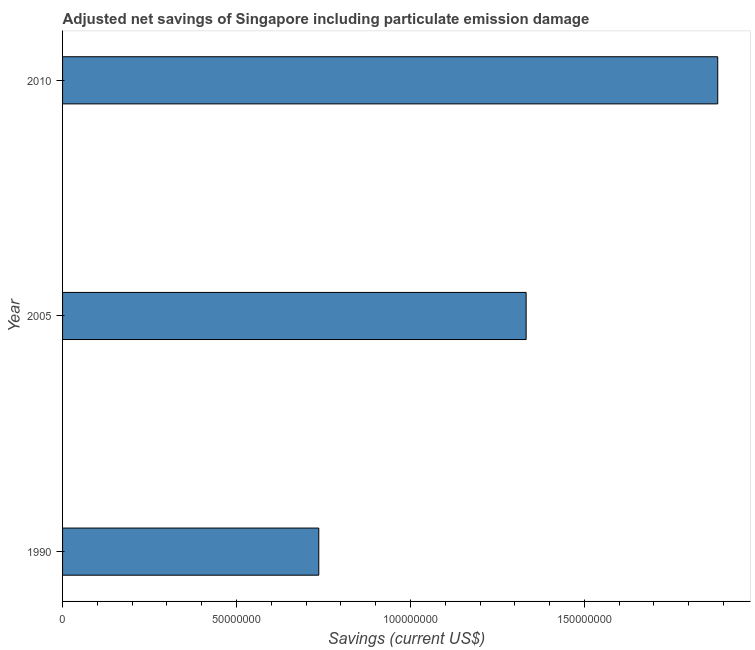What is the title of the graph?
Ensure brevity in your answer.  Adjusted net savings of Singapore including particulate emission damage. What is the label or title of the X-axis?
Offer a terse response. Savings (current US$). What is the label or title of the Y-axis?
Offer a very short reply. Year. What is the adjusted net savings in 2010?
Provide a short and direct response. 1.88e+08. Across all years, what is the maximum adjusted net savings?
Give a very brief answer. 1.88e+08. Across all years, what is the minimum adjusted net savings?
Make the answer very short. 7.36e+07. What is the sum of the adjusted net savings?
Give a very brief answer. 3.95e+08. What is the difference between the adjusted net savings in 1990 and 2005?
Provide a short and direct response. -5.96e+07. What is the average adjusted net savings per year?
Make the answer very short. 1.32e+08. What is the median adjusted net savings?
Offer a very short reply. 1.33e+08. In how many years, is the adjusted net savings greater than 80000000 US$?
Provide a succinct answer. 2. What is the ratio of the adjusted net savings in 2005 to that in 2010?
Make the answer very short. 0.71. Is the adjusted net savings in 2005 less than that in 2010?
Make the answer very short. Yes. What is the difference between the highest and the second highest adjusted net savings?
Your response must be concise. 5.51e+07. What is the difference between the highest and the lowest adjusted net savings?
Your answer should be compact. 1.15e+08. What is the difference between two consecutive major ticks on the X-axis?
Make the answer very short. 5.00e+07. Are the values on the major ticks of X-axis written in scientific E-notation?
Ensure brevity in your answer.  No. What is the Savings (current US$) of 1990?
Your answer should be very brief. 7.36e+07. What is the Savings (current US$) in 2005?
Provide a succinct answer. 1.33e+08. What is the Savings (current US$) of 2010?
Your answer should be compact. 1.88e+08. What is the difference between the Savings (current US$) in 1990 and 2005?
Provide a short and direct response. -5.96e+07. What is the difference between the Savings (current US$) in 1990 and 2010?
Your answer should be compact. -1.15e+08. What is the difference between the Savings (current US$) in 2005 and 2010?
Give a very brief answer. -5.51e+07. What is the ratio of the Savings (current US$) in 1990 to that in 2005?
Your answer should be very brief. 0.55. What is the ratio of the Savings (current US$) in 1990 to that in 2010?
Ensure brevity in your answer.  0.39. What is the ratio of the Savings (current US$) in 2005 to that in 2010?
Provide a succinct answer. 0.71. 